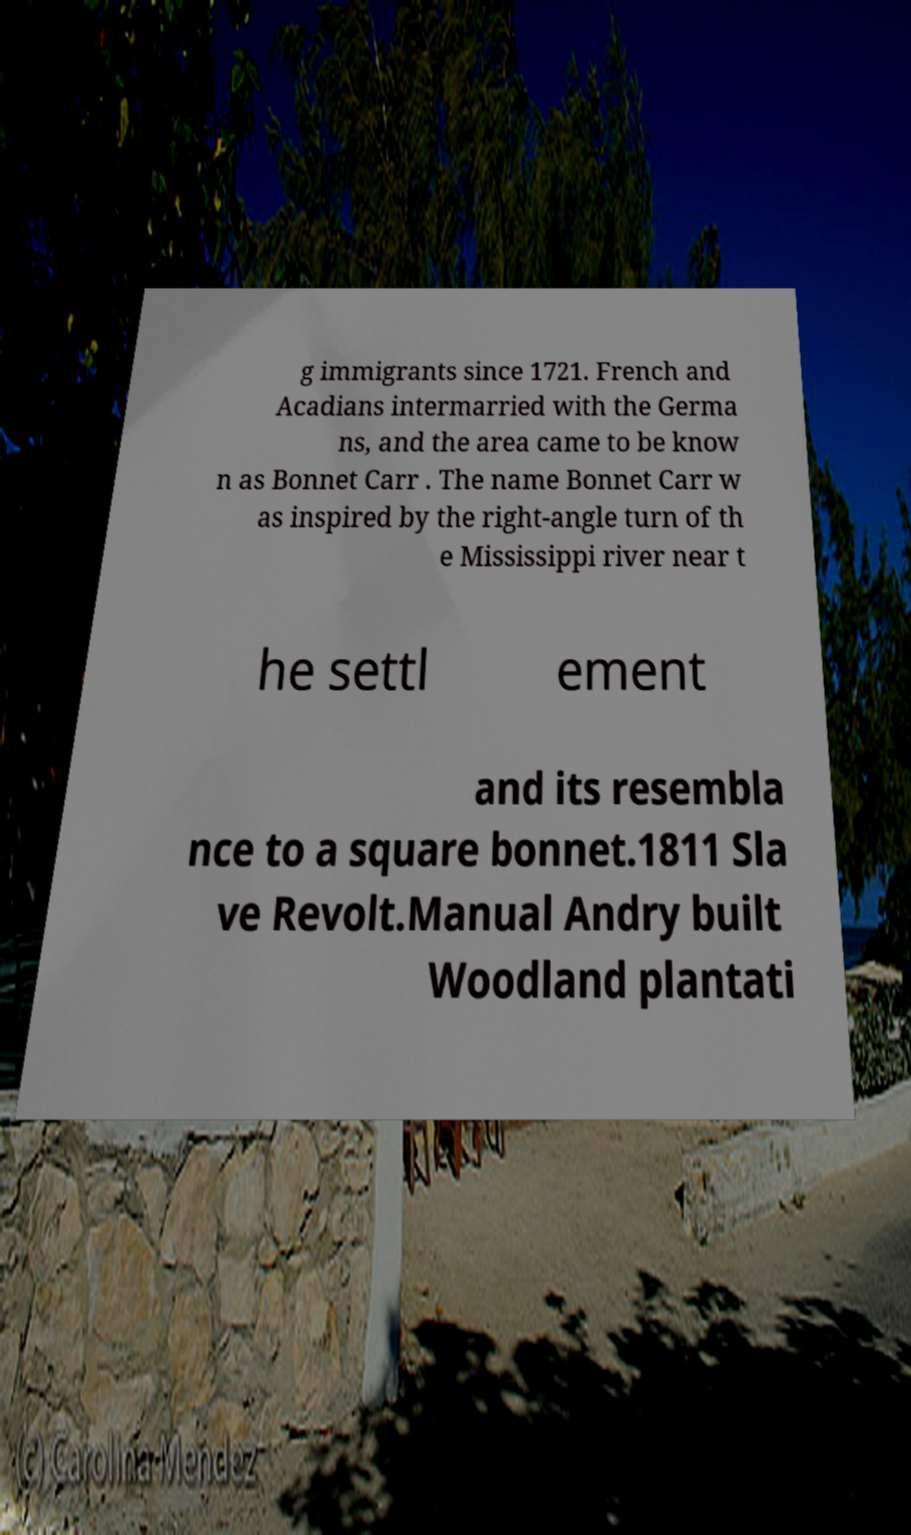Please identify and transcribe the text found in this image. g immigrants since 1721. French and Acadians intermarried with the Germa ns, and the area came to be know n as Bonnet Carr . The name Bonnet Carr w as inspired by the right-angle turn of th e Mississippi river near t he settl ement and its resembla nce to a square bonnet.1811 Sla ve Revolt.Manual Andry built Woodland plantati 